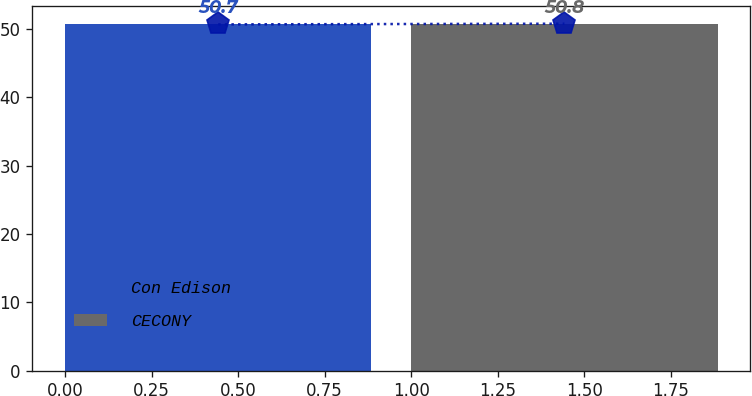Convert chart. <chart><loc_0><loc_0><loc_500><loc_500><bar_chart><fcel>Con Edison<fcel>CECONY<nl><fcel>50.7<fcel>50.8<nl></chart> 